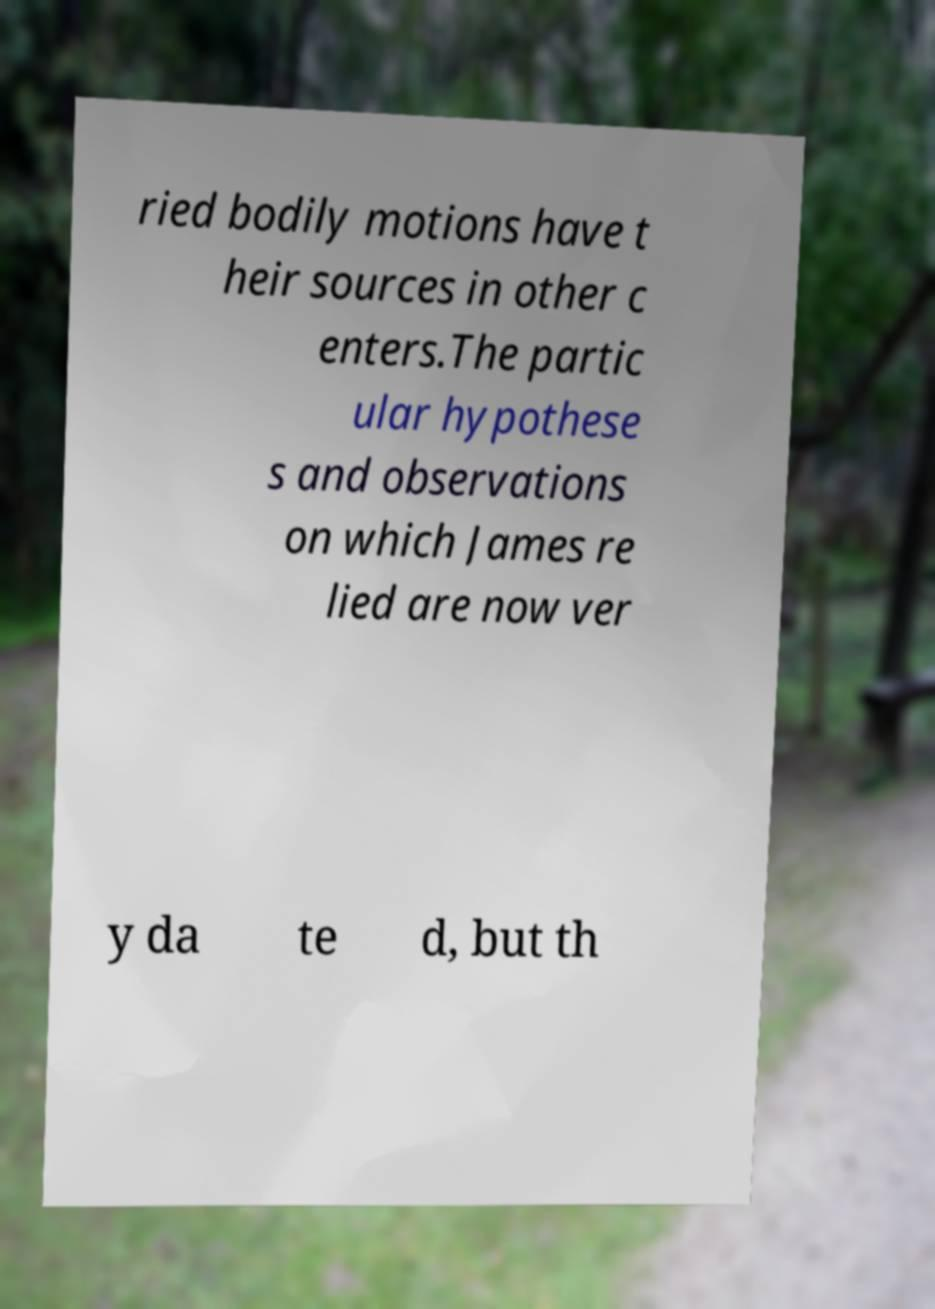Can you accurately transcribe the text from the provided image for me? ried bodily motions have t heir sources in other c enters.The partic ular hypothese s and observations on which James re lied are now ver y da te d, but th 